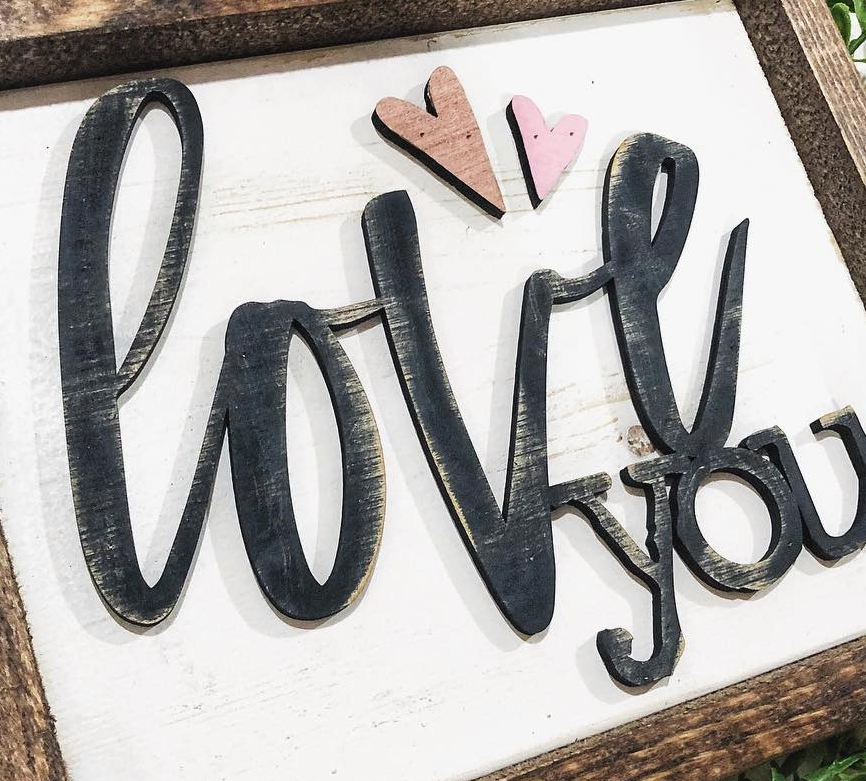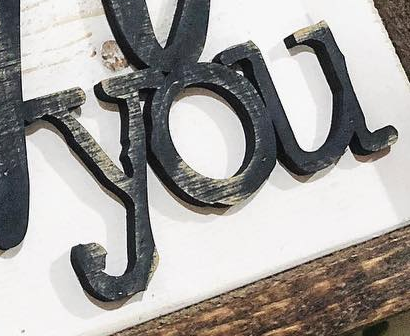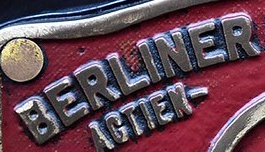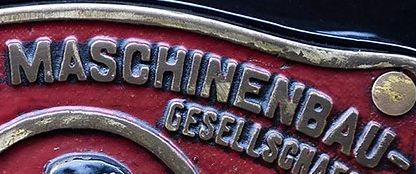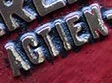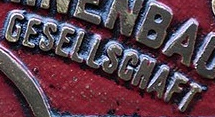What words can you see in these images in sequence, separated by a semicolon? love; you; BERLINER; MASCHINENBAU; AGTIEN; GESELLSGNAFT 